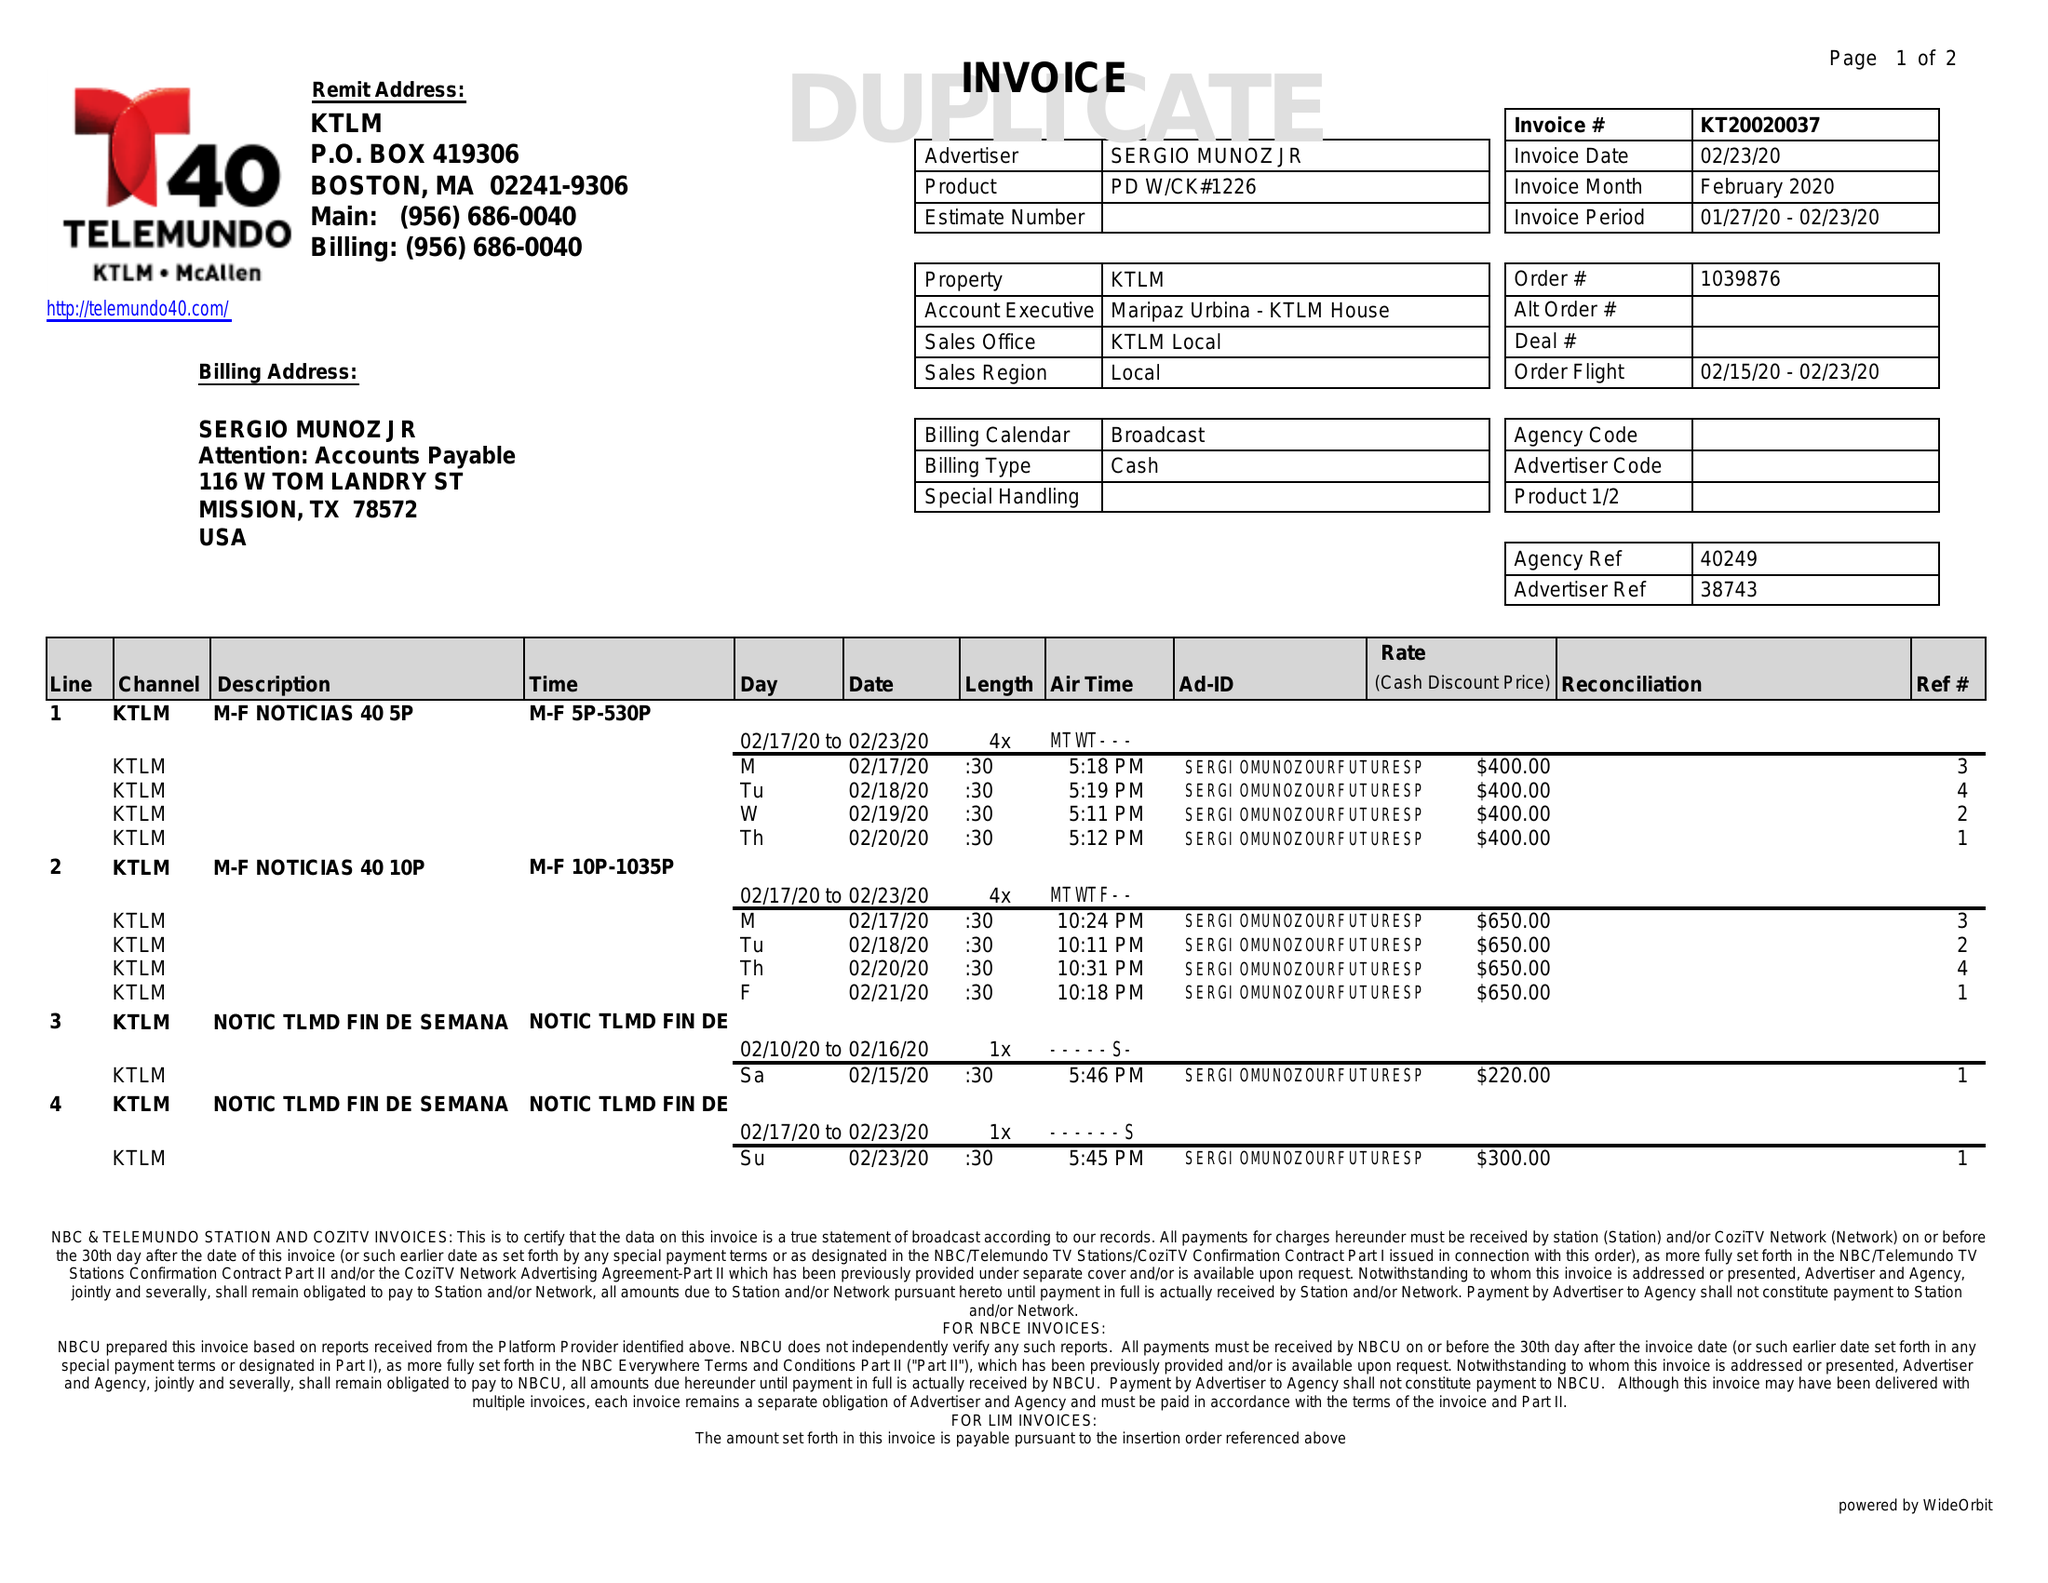What is the value for the contract_num?
Answer the question using a single word or phrase. KT20020037 